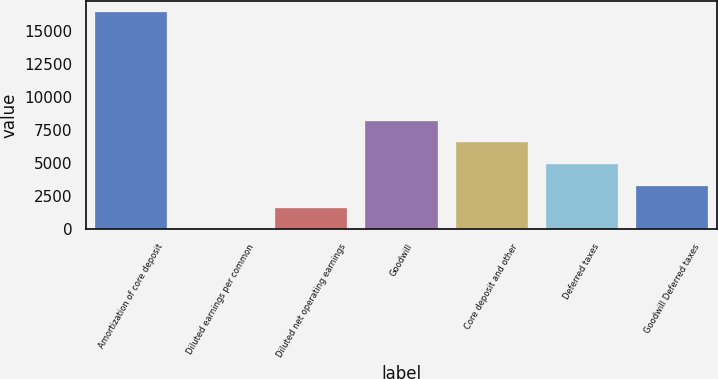Convert chart. <chart><loc_0><loc_0><loc_500><loc_500><bar_chart><fcel>Amortization of core deposit<fcel>Diluted earnings per common<fcel>Diluted net operating earnings<fcel>Goodwill<fcel>Core deposit and other<fcel>Deferred taxes<fcel>Goodwill Deferred taxes<nl><fcel>16457<fcel>1.95<fcel>1647.46<fcel>8229.49<fcel>6583.98<fcel>4938.48<fcel>3292.97<nl></chart> 